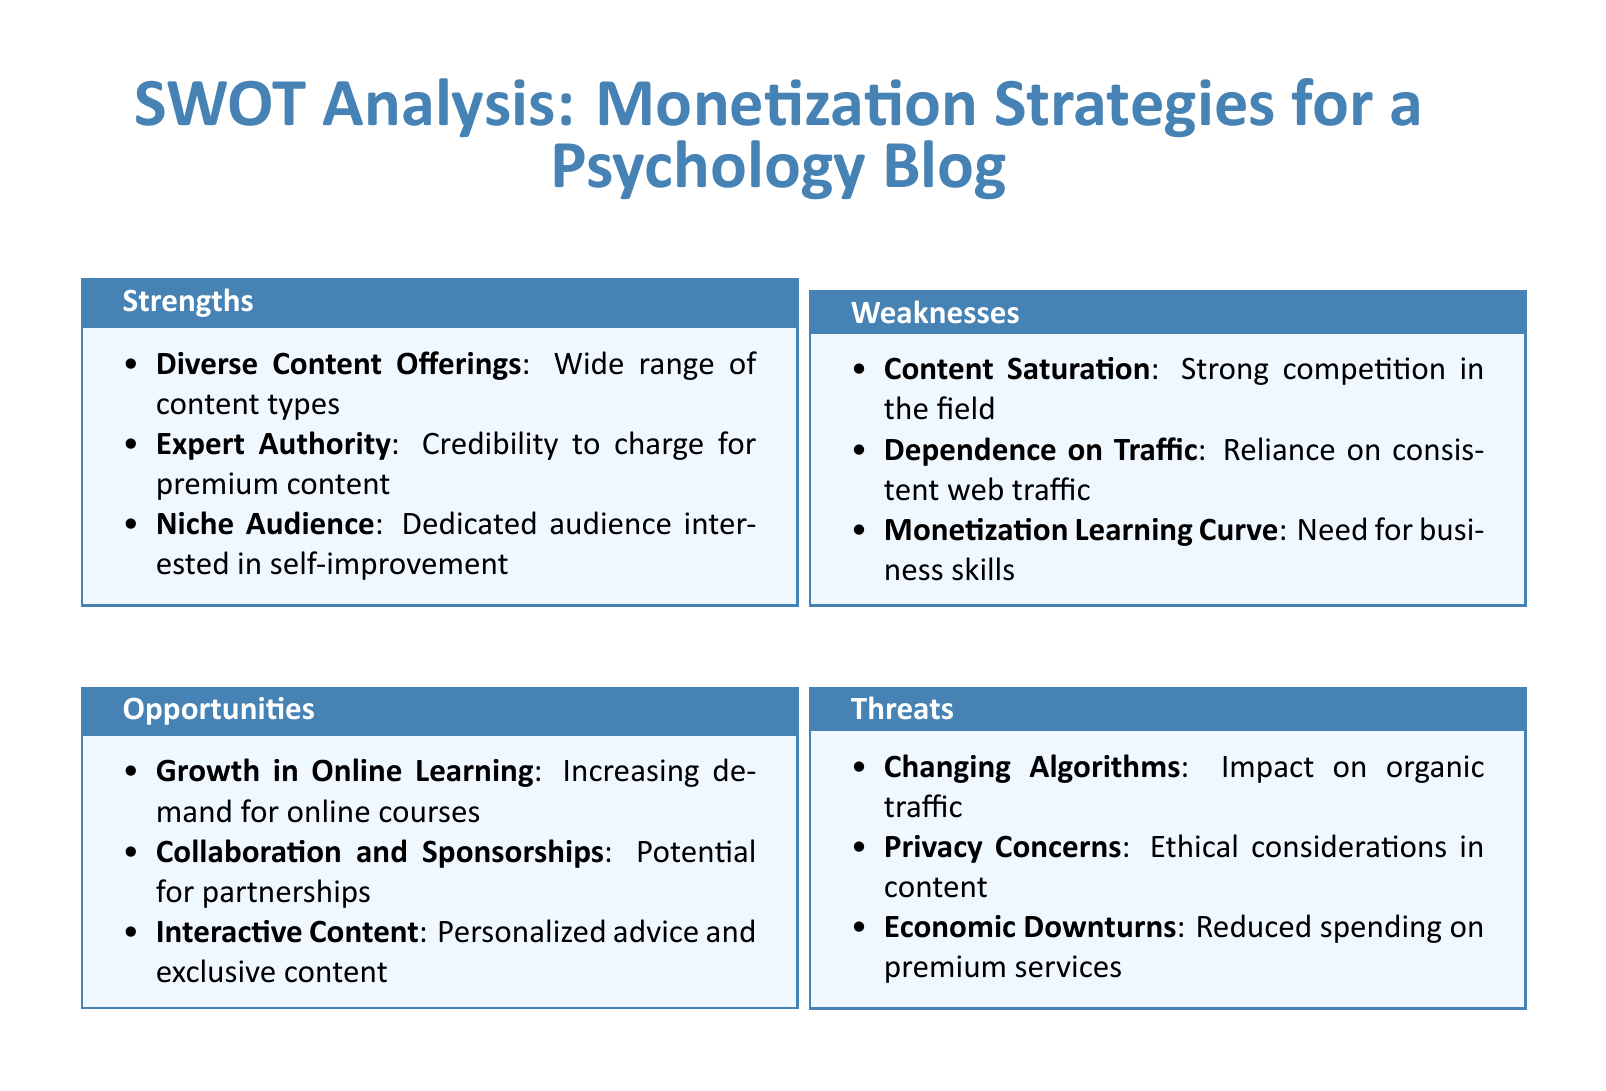What are the strengths listed in the document? The strengths are the favorable attributes of monetization strategies outlined in the SWOT analysis section.
Answer: Diverse Content Offerings, Expert Authority, Niche Audience How many weaknesses are identified? The weaknesses section includes the challenges faced in monetizing the blog, which adds up to three distinct points.
Answer: Three What opportunity involves collaboration? The opportunity reflects the possibility of forming partnerships to enhance monetization.
Answer: Collaboration and Sponsorships Which threat relates to ethical considerations? The identified threat discusses the implications surrounding user privacy in the context of the blog's content.
Answer: Privacy Concerns What is the impact of changing algorithms classified as? This refers to how changes in search engine algorithms affect the blog's organic traffic, posing a threat.
Answer: Threat 